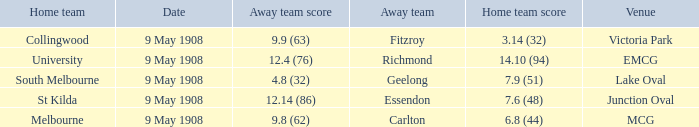Name the away team score for lake oval 4.8 (32). 